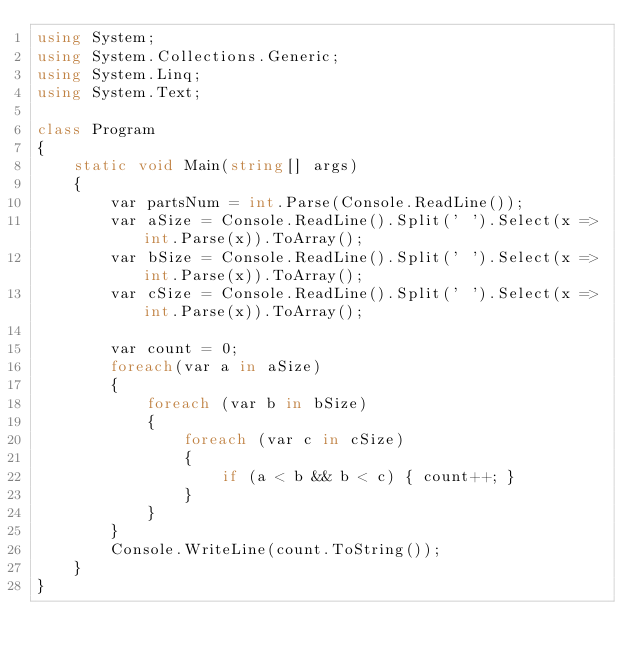Convert code to text. <code><loc_0><loc_0><loc_500><loc_500><_C#_>using System;
using System.Collections.Generic;
using System.Linq;
using System.Text;

class Program
{
    static void Main(string[] args)
    {
        var partsNum = int.Parse(Console.ReadLine());
        var aSize = Console.ReadLine().Split(' ').Select(x => int.Parse(x)).ToArray();
        var bSize = Console.ReadLine().Split(' ').Select(x => int.Parse(x)).ToArray();
        var cSize = Console.ReadLine().Split(' ').Select(x => int.Parse(x)).ToArray();

        var count = 0;
        foreach(var a in aSize)
        {
            foreach (var b in bSize)
            {
                foreach (var c in cSize)
                {
                    if (a < b && b < c) { count++; }
                }
            }
        }
        Console.WriteLine(count.ToString());
    }
}</code> 